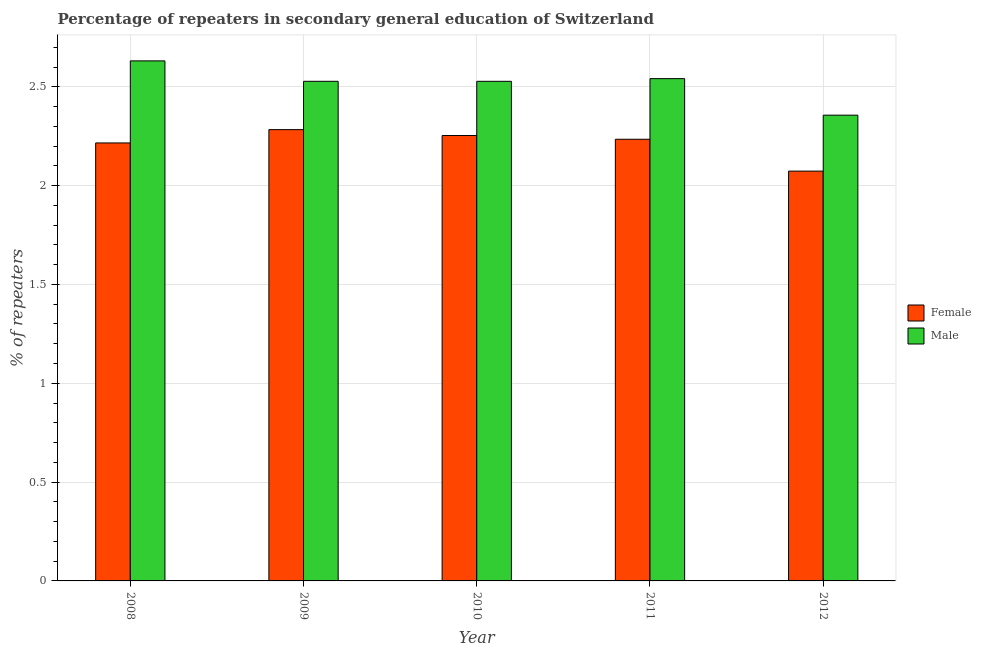How many different coloured bars are there?
Your answer should be compact. 2. How many groups of bars are there?
Provide a succinct answer. 5. Are the number of bars per tick equal to the number of legend labels?
Offer a terse response. Yes. What is the label of the 2nd group of bars from the left?
Ensure brevity in your answer.  2009. What is the percentage of female repeaters in 2010?
Offer a very short reply. 2.25. Across all years, what is the maximum percentage of female repeaters?
Your answer should be compact. 2.28. Across all years, what is the minimum percentage of male repeaters?
Your answer should be compact. 2.36. What is the total percentage of female repeaters in the graph?
Give a very brief answer. 11.06. What is the difference between the percentage of male repeaters in 2010 and that in 2012?
Offer a very short reply. 0.17. What is the difference between the percentage of female repeaters in 2012 and the percentage of male repeaters in 2010?
Offer a terse response. -0.18. What is the average percentage of male repeaters per year?
Keep it short and to the point. 2.52. What is the ratio of the percentage of female repeaters in 2011 to that in 2012?
Keep it short and to the point. 1.08. Is the percentage of male repeaters in 2008 less than that in 2012?
Provide a short and direct response. No. What is the difference between the highest and the second highest percentage of male repeaters?
Provide a succinct answer. 0.09. What is the difference between the highest and the lowest percentage of female repeaters?
Make the answer very short. 0.21. Are all the bars in the graph horizontal?
Your answer should be compact. No. How many years are there in the graph?
Offer a terse response. 5. Are the values on the major ticks of Y-axis written in scientific E-notation?
Offer a terse response. No. How many legend labels are there?
Your answer should be very brief. 2. How are the legend labels stacked?
Offer a very short reply. Vertical. What is the title of the graph?
Offer a terse response. Percentage of repeaters in secondary general education of Switzerland. What is the label or title of the Y-axis?
Ensure brevity in your answer.  % of repeaters. What is the % of repeaters of Female in 2008?
Provide a short and direct response. 2.22. What is the % of repeaters of Male in 2008?
Your answer should be compact. 2.63. What is the % of repeaters in Female in 2009?
Ensure brevity in your answer.  2.28. What is the % of repeaters in Male in 2009?
Ensure brevity in your answer.  2.53. What is the % of repeaters of Female in 2010?
Make the answer very short. 2.25. What is the % of repeaters of Male in 2010?
Give a very brief answer. 2.53. What is the % of repeaters in Female in 2011?
Provide a short and direct response. 2.23. What is the % of repeaters in Male in 2011?
Make the answer very short. 2.54. What is the % of repeaters in Female in 2012?
Your answer should be compact. 2.07. What is the % of repeaters of Male in 2012?
Offer a very short reply. 2.36. Across all years, what is the maximum % of repeaters in Female?
Keep it short and to the point. 2.28. Across all years, what is the maximum % of repeaters in Male?
Keep it short and to the point. 2.63. Across all years, what is the minimum % of repeaters of Female?
Your answer should be compact. 2.07. Across all years, what is the minimum % of repeaters of Male?
Ensure brevity in your answer.  2.36. What is the total % of repeaters of Female in the graph?
Your response must be concise. 11.06. What is the total % of repeaters in Male in the graph?
Make the answer very short. 12.58. What is the difference between the % of repeaters of Female in 2008 and that in 2009?
Offer a very short reply. -0.07. What is the difference between the % of repeaters of Male in 2008 and that in 2009?
Your answer should be very brief. 0.1. What is the difference between the % of repeaters of Female in 2008 and that in 2010?
Your answer should be compact. -0.04. What is the difference between the % of repeaters of Male in 2008 and that in 2010?
Provide a succinct answer. 0.1. What is the difference between the % of repeaters in Female in 2008 and that in 2011?
Make the answer very short. -0.02. What is the difference between the % of repeaters of Male in 2008 and that in 2011?
Give a very brief answer. 0.09. What is the difference between the % of repeaters of Female in 2008 and that in 2012?
Ensure brevity in your answer.  0.14. What is the difference between the % of repeaters of Male in 2008 and that in 2012?
Make the answer very short. 0.27. What is the difference between the % of repeaters in Female in 2009 and that in 2010?
Make the answer very short. 0.03. What is the difference between the % of repeaters of Female in 2009 and that in 2011?
Give a very brief answer. 0.05. What is the difference between the % of repeaters in Male in 2009 and that in 2011?
Provide a succinct answer. -0.01. What is the difference between the % of repeaters of Female in 2009 and that in 2012?
Your response must be concise. 0.21. What is the difference between the % of repeaters of Male in 2009 and that in 2012?
Offer a terse response. 0.17. What is the difference between the % of repeaters in Female in 2010 and that in 2011?
Your answer should be very brief. 0.02. What is the difference between the % of repeaters in Male in 2010 and that in 2011?
Give a very brief answer. -0.01. What is the difference between the % of repeaters in Female in 2010 and that in 2012?
Provide a succinct answer. 0.18. What is the difference between the % of repeaters in Male in 2010 and that in 2012?
Offer a very short reply. 0.17. What is the difference between the % of repeaters of Female in 2011 and that in 2012?
Offer a very short reply. 0.16. What is the difference between the % of repeaters in Male in 2011 and that in 2012?
Your answer should be very brief. 0.18. What is the difference between the % of repeaters in Female in 2008 and the % of repeaters in Male in 2009?
Offer a very short reply. -0.31. What is the difference between the % of repeaters in Female in 2008 and the % of repeaters in Male in 2010?
Keep it short and to the point. -0.31. What is the difference between the % of repeaters in Female in 2008 and the % of repeaters in Male in 2011?
Give a very brief answer. -0.33. What is the difference between the % of repeaters in Female in 2008 and the % of repeaters in Male in 2012?
Your answer should be compact. -0.14. What is the difference between the % of repeaters in Female in 2009 and the % of repeaters in Male in 2010?
Make the answer very short. -0.24. What is the difference between the % of repeaters of Female in 2009 and the % of repeaters of Male in 2011?
Your answer should be very brief. -0.26. What is the difference between the % of repeaters of Female in 2009 and the % of repeaters of Male in 2012?
Your response must be concise. -0.07. What is the difference between the % of repeaters of Female in 2010 and the % of repeaters of Male in 2011?
Offer a very short reply. -0.29. What is the difference between the % of repeaters of Female in 2010 and the % of repeaters of Male in 2012?
Your answer should be compact. -0.1. What is the difference between the % of repeaters in Female in 2011 and the % of repeaters in Male in 2012?
Provide a short and direct response. -0.12. What is the average % of repeaters in Female per year?
Your response must be concise. 2.21. What is the average % of repeaters of Male per year?
Offer a very short reply. 2.52. In the year 2008, what is the difference between the % of repeaters in Female and % of repeaters in Male?
Provide a succinct answer. -0.42. In the year 2009, what is the difference between the % of repeaters of Female and % of repeaters of Male?
Offer a very short reply. -0.24. In the year 2010, what is the difference between the % of repeaters in Female and % of repeaters in Male?
Your answer should be compact. -0.27. In the year 2011, what is the difference between the % of repeaters in Female and % of repeaters in Male?
Make the answer very short. -0.31. In the year 2012, what is the difference between the % of repeaters in Female and % of repeaters in Male?
Make the answer very short. -0.28. What is the ratio of the % of repeaters in Female in 2008 to that in 2009?
Your answer should be compact. 0.97. What is the ratio of the % of repeaters of Male in 2008 to that in 2009?
Your answer should be very brief. 1.04. What is the ratio of the % of repeaters of Female in 2008 to that in 2010?
Keep it short and to the point. 0.98. What is the ratio of the % of repeaters in Male in 2008 to that in 2010?
Ensure brevity in your answer.  1.04. What is the ratio of the % of repeaters in Male in 2008 to that in 2011?
Your answer should be compact. 1.04. What is the ratio of the % of repeaters of Female in 2008 to that in 2012?
Your answer should be very brief. 1.07. What is the ratio of the % of repeaters of Male in 2008 to that in 2012?
Offer a terse response. 1.12. What is the ratio of the % of repeaters in Female in 2009 to that in 2010?
Your answer should be very brief. 1.01. What is the ratio of the % of repeaters of Female in 2009 to that in 2011?
Keep it short and to the point. 1.02. What is the ratio of the % of repeaters in Female in 2009 to that in 2012?
Your answer should be very brief. 1.1. What is the ratio of the % of repeaters in Male in 2009 to that in 2012?
Provide a succinct answer. 1.07. What is the ratio of the % of repeaters of Female in 2010 to that in 2011?
Your answer should be very brief. 1.01. What is the ratio of the % of repeaters of Male in 2010 to that in 2011?
Provide a succinct answer. 0.99. What is the ratio of the % of repeaters of Female in 2010 to that in 2012?
Your answer should be very brief. 1.09. What is the ratio of the % of repeaters in Male in 2010 to that in 2012?
Provide a succinct answer. 1.07. What is the ratio of the % of repeaters in Female in 2011 to that in 2012?
Your answer should be compact. 1.08. What is the ratio of the % of repeaters in Male in 2011 to that in 2012?
Provide a succinct answer. 1.08. What is the difference between the highest and the second highest % of repeaters of Female?
Offer a very short reply. 0.03. What is the difference between the highest and the second highest % of repeaters of Male?
Make the answer very short. 0.09. What is the difference between the highest and the lowest % of repeaters of Female?
Your response must be concise. 0.21. What is the difference between the highest and the lowest % of repeaters of Male?
Your answer should be very brief. 0.27. 